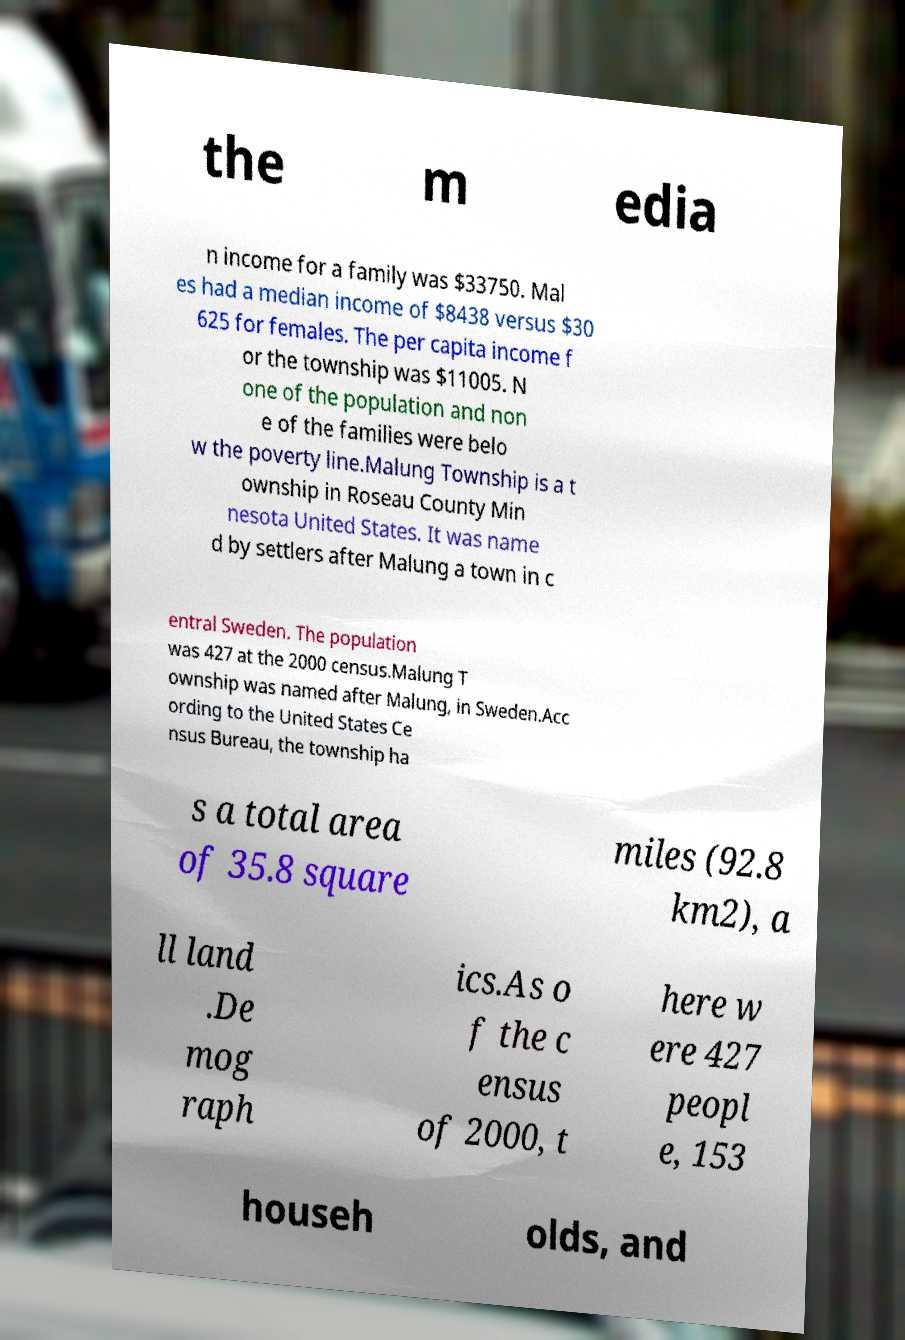There's text embedded in this image that I need extracted. Can you transcribe it verbatim? the m edia n income for a family was $33750. Mal es had a median income of $8438 versus $30 625 for females. The per capita income f or the township was $11005. N one of the population and non e of the families were belo w the poverty line.Malung Township is a t ownship in Roseau County Min nesota United States. It was name d by settlers after Malung a town in c entral Sweden. The population was 427 at the 2000 census.Malung T ownship was named after Malung, in Sweden.Acc ording to the United States Ce nsus Bureau, the township ha s a total area of 35.8 square miles (92.8 km2), a ll land .De mog raph ics.As o f the c ensus of 2000, t here w ere 427 peopl e, 153 househ olds, and 